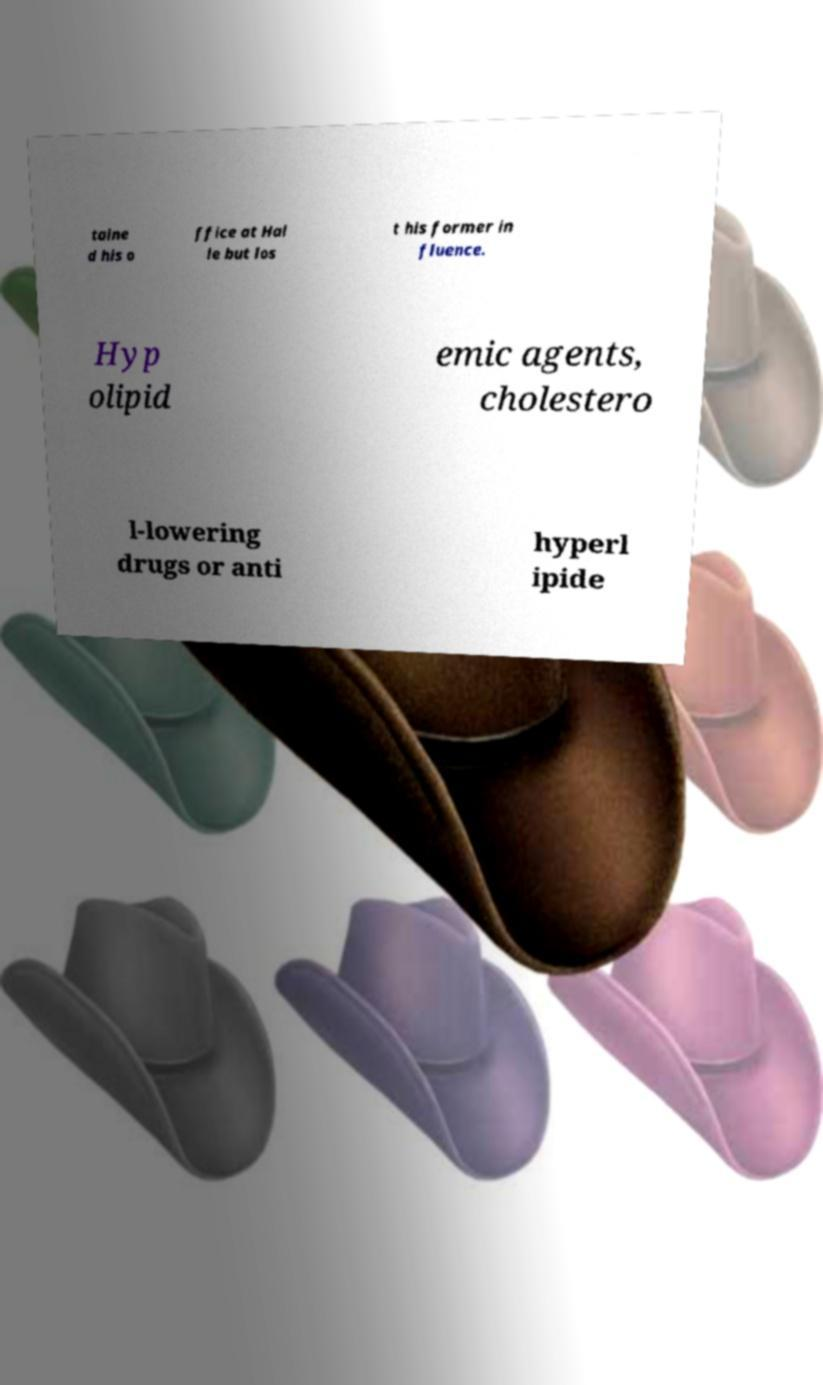There's text embedded in this image that I need extracted. Can you transcribe it verbatim? taine d his o ffice at Hal le but los t his former in fluence. Hyp olipid emic agents, cholestero l-lowering drugs or anti hyperl ipide 